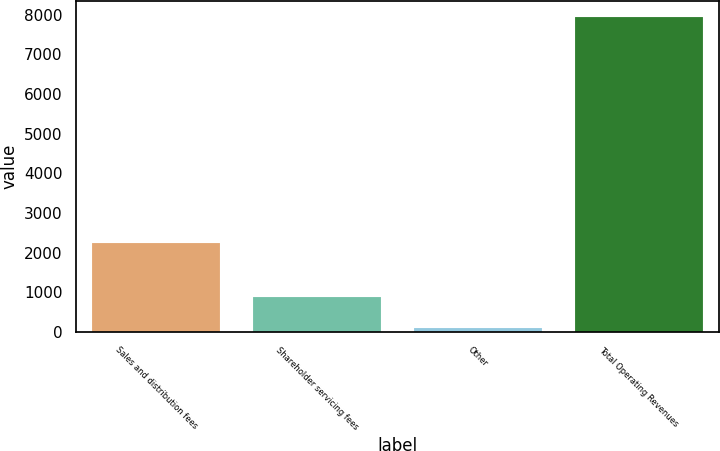Convert chart. <chart><loc_0><loc_0><loc_500><loc_500><bar_chart><fcel>Sales and distribution fees<fcel>Shareholder servicing fees<fcel>Other<fcel>Total Operating Revenues<nl><fcel>2252.4<fcel>890<fcel>105.7<fcel>7948.7<nl></chart> 